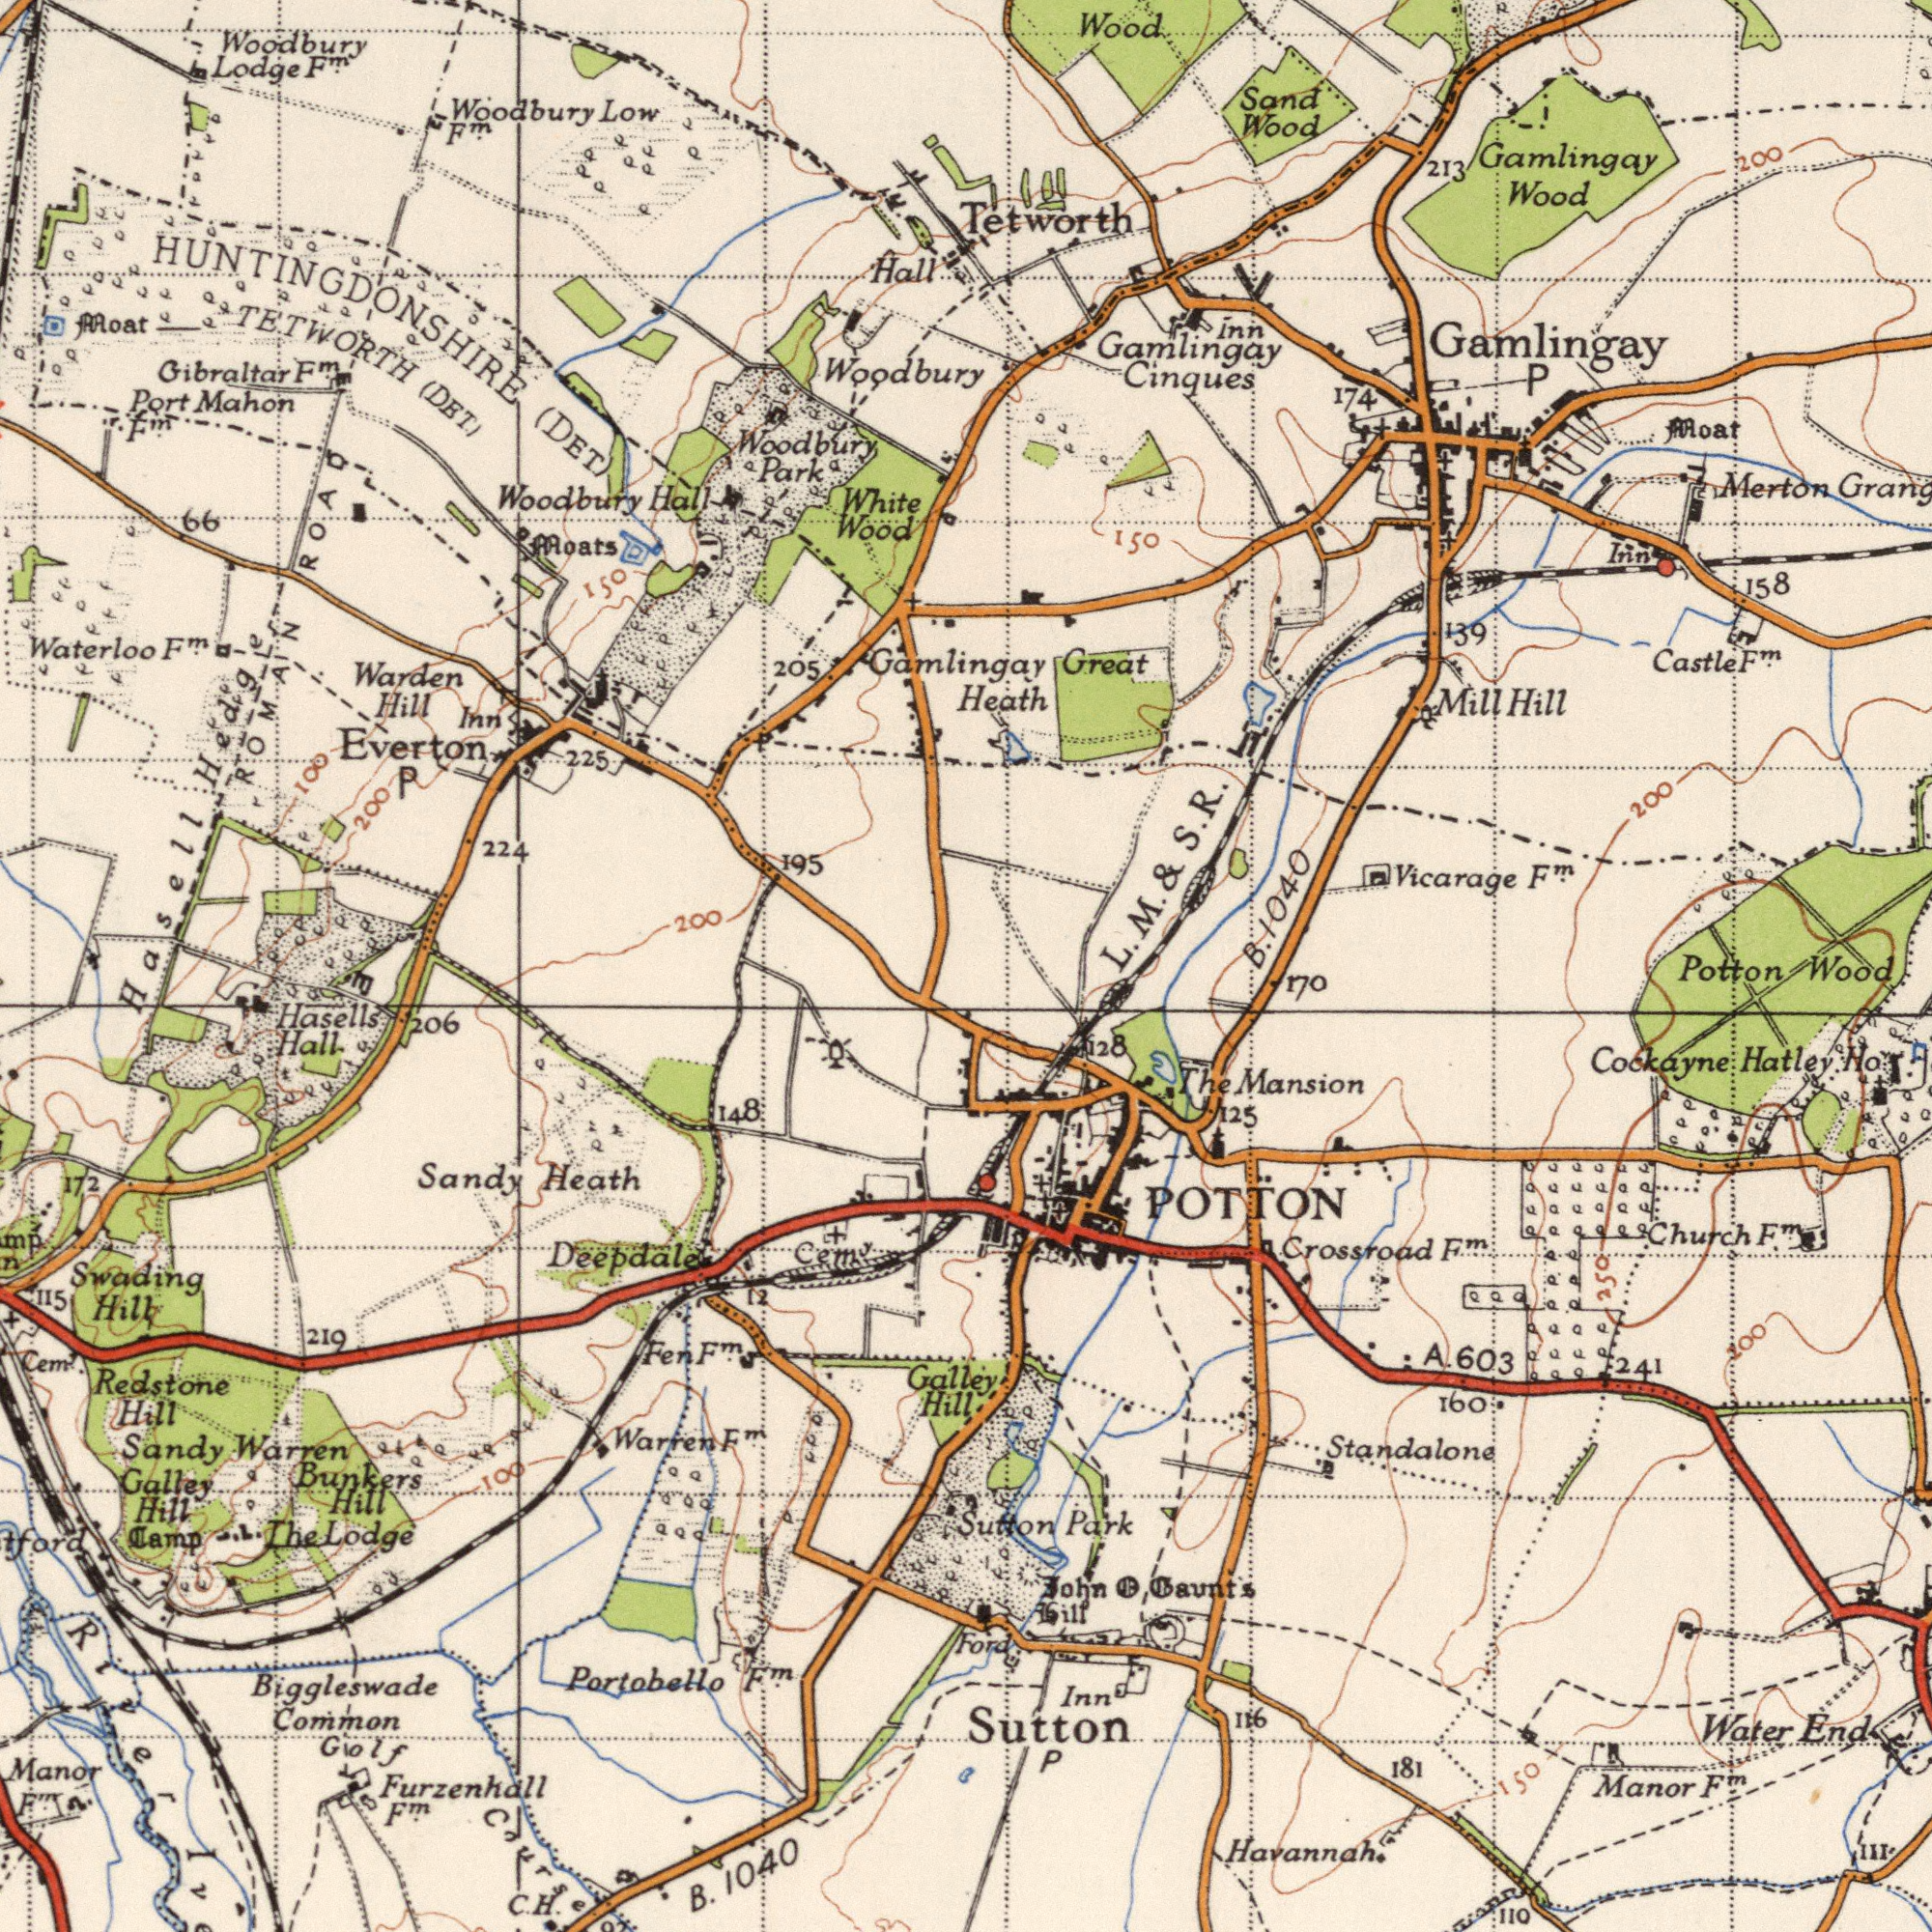What text can you see in the bottom-right section? Havannah. Sutton Crossroad Cockayne Water Manor Hatley Park 181 Church Mansion 160 116 Inn 110 111 F<sup>m</sup>. Standalone Ho John 128 F<sup>m</sup>. Gaunt's F<sup>m</sup>. POTTON 125 603 241 170 The End Sutton P Hill Ford Potton 150 A. Wood 200 250 What text is shown in the top-right quadrant? Gamlingay Gamlingay Tetworth 1040 Wood Cinques Merton Vicarage Wood Great Heath Wood Mill Hill 213 Gamlingay Moat 158 Castle Sand 139 F<sup>m</sup>. 174 P Inn 200 Inn 200 150 Gamlingay F<sup>m</sup>. B. L. M. & S. R. What text appears in the top-left area of the image? Woodbury Wood Everton Woodbury Woodbury Woodbury Gibraltar Mahon Warden (DET .) Hasell 224 White Hill Lodge Low TETWORTH Hall Port 205 F<sup>m</sup>. Woodbury ROAD 195 Park 225 Moat Hall (DET) 200 Waterloo 100 ROMAN 200 P Moats F<sup>m</sup>. 150 F<sup>m</sup>. F<sup>m</sup>. F<sup>m</sup>. HUNTINGDONSHIRE Inn 66 Hedge What text is visible in the lower-left corner? Portobello Biggleswade Swading B. 1040 Deepdale Warren Manor Common Cem<sup>y</sup>. Sandy Warren Lodge The Heath Galley Hill 219 Redstone 148 206 Sandy 172 C. 12 Hill Hill Galley Hall Camp Hill Cem<sup>y</sup>. F<sup>m</sup>. Hasells Golf Furzenhall 115 100 F<sup>m</sup>. River Hil M<sup>m</sup>. Fen Course F<sup>m</sup>. F<sup>m</sup>. Bunkers H. E 